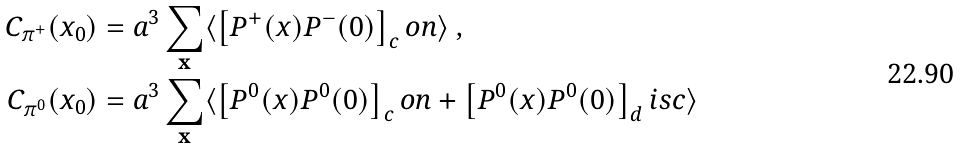<formula> <loc_0><loc_0><loc_500><loc_500>C _ { \pi ^ { + } } ( x _ { 0 } ) & = a ^ { 3 } \sum _ { \mathbf x } \langle \left [ P ^ { + } ( x ) P ^ { - } ( 0 ) \right ] _ { c } o n \rangle \ , \\ C _ { \pi ^ { 0 } } ( x _ { 0 } ) & = a ^ { 3 } \sum _ { \mathbf x } \langle \left [ P ^ { 0 } ( x ) P ^ { 0 } ( 0 ) \right ] _ { c } o n + \left [ P ^ { 0 } ( x ) P ^ { 0 } ( 0 ) \right ] _ { d } i s c \rangle</formula> 